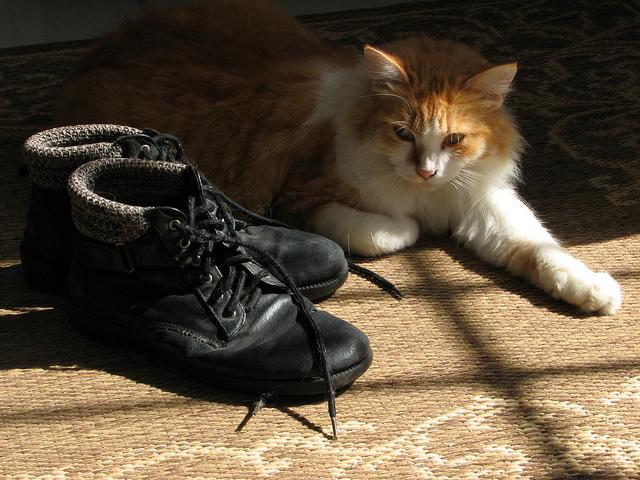What colors are the cat on the right?
Write a very short answer. Orange and white. What size boots are they?
Write a very short answer. 8. Is this an adult cat?
Concise answer only. Yes. Is that cat angry?
Give a very brief answer. No. Are the boot laces tied?
Give a very brief answer. No. Is the cat playing?
Be succinct. No. 